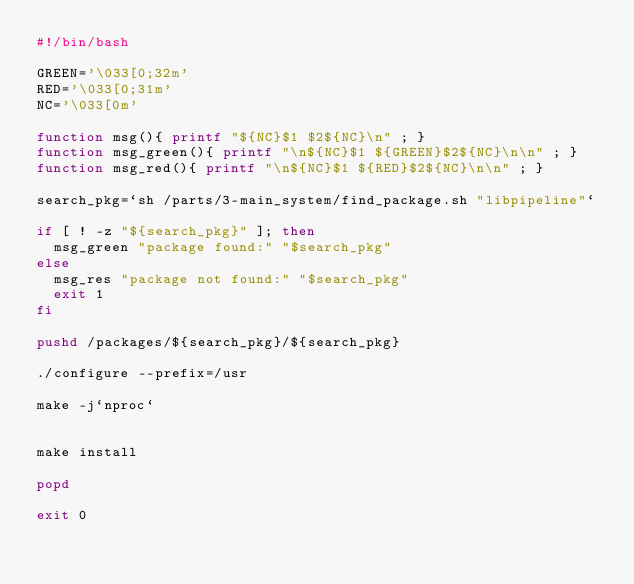Convert code to text. <code><loc_0><loc_0><loc_500><loc_500><_Bash_>#!/bin/bash

GREEN='\033[0;32m'
RED='\033[0;31m'
NC='\033[0m'

function msg(){ printf "${NC}$1 $2${NC}\n" ; }
function msg_green(){ printf "\n${NC}$1 ${GREEN}$2${NC}\n\n" ; }
function msg_red(){ printf "\n${NC}$1 ${RED}$2${NC}\n\n" ; }

search_pkg=`sh /parts/3-main_system/find_package.sh "libpipeline"`

if [ ! -z "${search_pkg}" ]; then
	msg_green "package found:" "$search_pkg"
else
	msg_res "package not found:" "$search_pkg"
	exit 1
fi

pushd /packages/${search_pkg}/${search_pkg}

./configure --prefix=/usr

make -j`nproc`


make install

popd

exit 0


</code> 